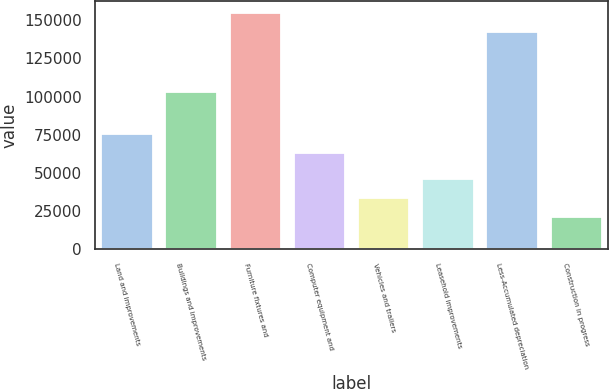Convert chart to OTSL. <chart><loc_0><loc_0><loc_500><loc_500><bar_chart><fcel>Land and improvements<fcel>Buildings and improvements<fcel>Furniture fixtures and<fcel>Computer equipment and<fcel>Vehicles and trailers<fcel>Leasehold improvements<fcel>Less-Accumulated depreciation<fcel>Construction in progress<nl><fcel>75771.6<fcel>103198<fcel>154832<fcel>63341<fcel>33320.6<fcel>45751.2<fcel>142401<fcel>20890<nl></chart> 